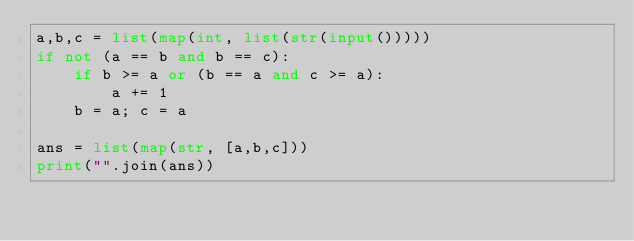Convert code to text. <code><loc_0><loc_0><loc_500><loc_500><_Python_>a,b,c = list(map(int, list(str(input()))))
if not (a == b and b == c):
    if b >= a or (b == a and c >= a):
        a += 1
    b = a; c = a

ans = list(map(str, [a,b,c]))
print("".join(ans))</code> 